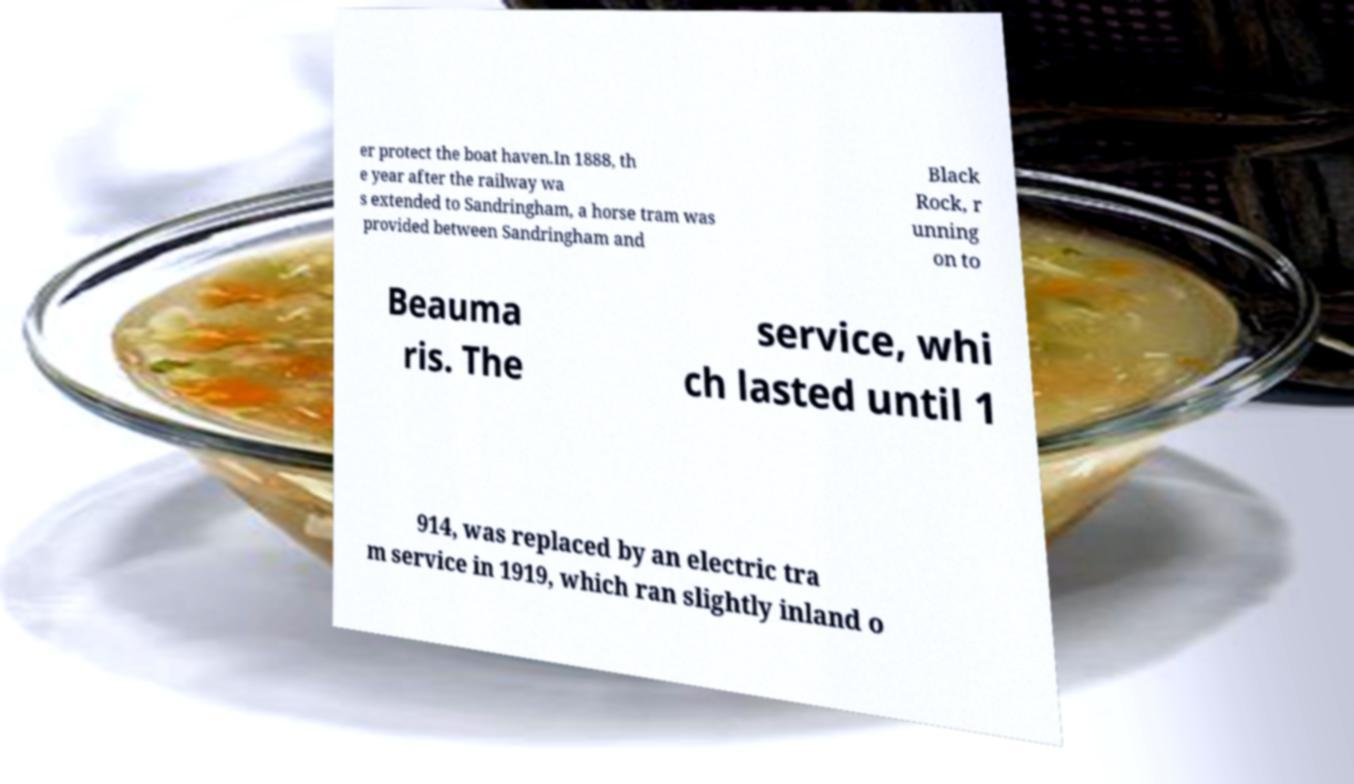Could you extract and type out the text from this image? er protect the boat haven.In 1888, th e year after the railway wa s extended to Sandringham, a horse tram was provided between Sandringham and Black Rock, r unning on to Beauma ris. The service, whi ch lasted until 1 914, was replaced by an electric tra m service in 1919, which ran slightly inland o 